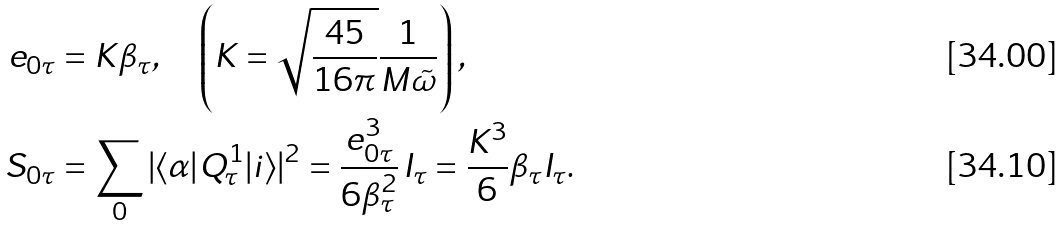<formula> <loc_0><loc_0><loc_500><loc_500>e _ { 0 \tau } & = K \beta _ { \tau } , \quad \left ( K = \sqrt { \frac { 4 5 } { 1 6 \pi } } \frac { 1 } { M \tilde { \omega } } \right ) , \\ S _ { 0 \tau } & = \sum _ { 0 } | \langle \alpha | Q _ { \tau } ^ { 1 } | i \rangle | ^ { 2 } = \frac { e _ { 0 \tau } ^ { 3 } } { 6 \beta _ { \tau } ^ { 2 } } \, I _ { \tau } = \frac { K ^ { 3 } } { 6 } \beta _ { \tau } I _ { \tau } .</formula> 